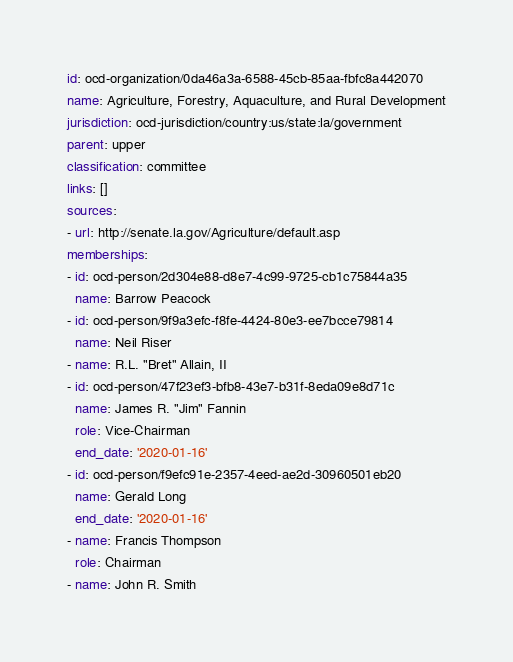<code> <loc_0><loc_0><loc_500><loc_500><_YAML_>id: ocd-organization/0da46a3a-6588-45cb-85aa-fbfc8a442070
name: Agriculture, Forestry, Aquaculture, and Rural Development
jurisdiction: ocd-jurisdiction/country:us/state:la/government
parent: upper
classification: committee
links: []
sources:
- url: http://senate.la.gov/Agriculture/default.asp
memberships:
- id: ocd-person/2d304e88-d8e7-4c99-9725-cb1c75844a35
  name: Barrow Peacock
- id: ocd-person/9f9a3efc-f8fe-4424-80e3-ee7bcce79814
  name: Neil Riser
- name: R.L. "Bret" Allain, II
- id: ocd-person/47f23ef3-bfb8-43e7-b31f-8eda09e8d71c
  name: James R. "Jim" Fannin
  role: Vice-Chairman
  end_date: '2020-01-16'
- id: ocd-person/f9efc91e-2357-4eed-ae2d-30960501eb20
  name: Gerald Long
  end_date: '2020-01-16'
- name: Francis Thompson
  role: Chairman
- name: John R. Smith
</code> 